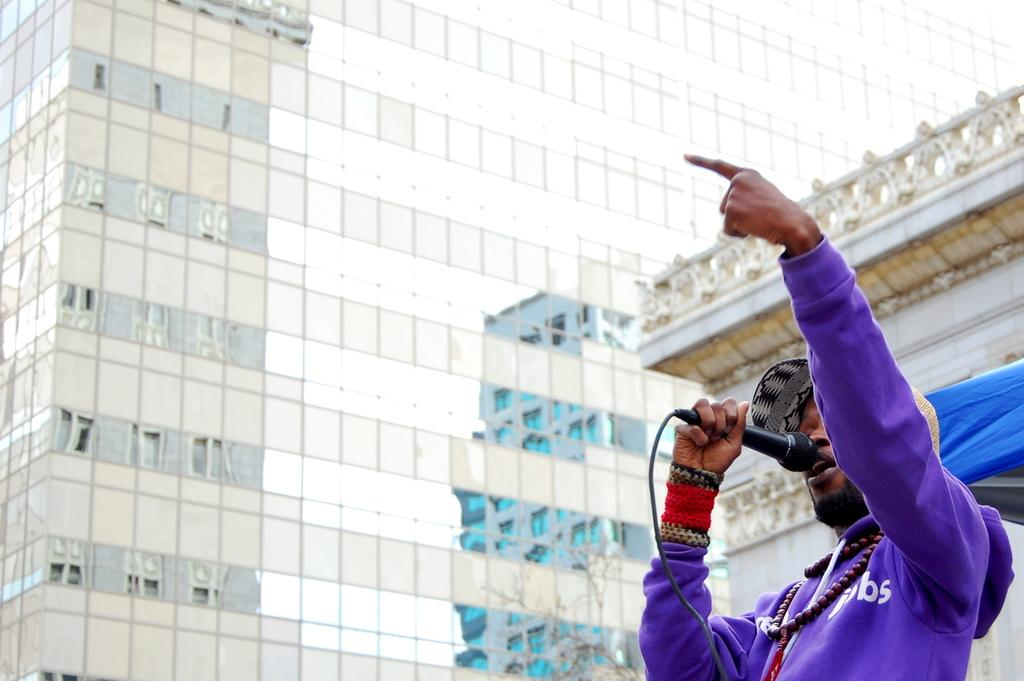What is the man in the image doing? The man is standing at the bottom of the image and appears to be singing. What is the man holding in the image? The man is holding a microphone in the image. What can be seen in the background of the image? There are buildings visible in the background of the image. What type of winter clothing is the man wearing in the image? There is no mention of winter clothing or any specific season in the image, so it cannot be determined from the image. 